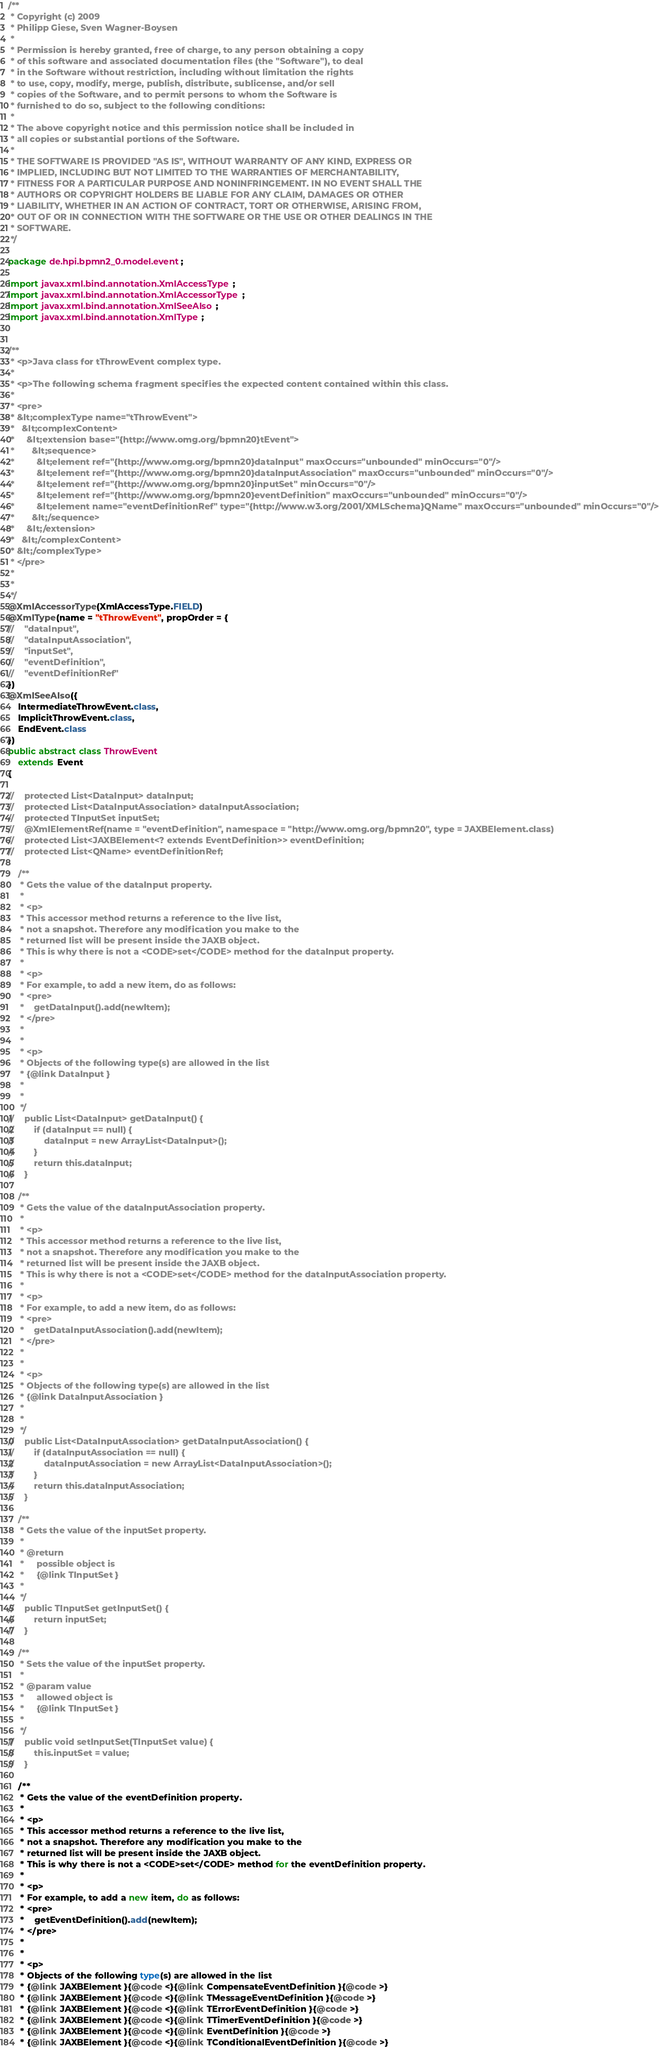<code> <loc_0><loc_0><loc_500><loc_500><_Java_>/**
 * Copyright (c) 2009
 * Philipp Giese, Sven Wagner-Boysen
 * 
 * Permission is hereby granted, free of charge, to any person obtaining a copy
 * of this software and associated documentation files (the "Software"), to deal
 * in the Software without restriction, including without limitation the rights
 * to use, copy, modify, merge, publish, distribute, sublicense, and/or sell
 * copies of the Software, and to permit persons to whom the Software is
 * furnished to do so, subject to the following conditions:
 * 
 * The above copyright notice and this permission notice shall be included in
 * all copies or substantial portions of the Software.
 * 
 * THE SOFTWARE IS PROVIDED "AS IS", WITHOUT WARRANTY OF ANY KIND, EXPRESS OR
 * IMPLIED, INCLUDING BUT NOT LIMITED TO THE WARRANTIES OF MERCHANTABILITY,
 * FITNESS FOR A PARTICULAR PURPOSE AND NONINFRINGEMENT. IN NO EVENT SHALL THE
 * AUTHORS OR COPYRIGHT HOLDERS BE LIABLE FOR ANY CLAIM, DAMAGES OR OTHER
 * LIABILITY, WHETHER IN AN ACTION OF CONTRACT, TORT OR OTHERWISE, ARISING FROM,
 * OUT OF OR IN CONNECTION WITH THE SOFTWARE OR THE USE OR OTHER DEALINGS IN THE
 * SOFTWARE.
 */

package de.hpi.bpmn2_0.model.event;

import javax.xml.bind.annotation.XmlAccessType;
import javax.xml.bind.annotation.XmlAccessorType;
import javax.xml.bind.annotation.XmlSeeAlso;
import javax.xml.bind.annotation.XmlType;


/**
 * <p>Java class for tThrowEvent complex type.
 * 
 * <p>The following schema fragment specifies the expected content contained within this class.
 * 
 * <pre>
 * &lt;complexType name="tThrowEvent">
 *   &lt;complexContent>
 *     &lt;extension base="{http://www.omg.org/bpmn20}tEvent">
 *       &lt;sequence>
 *         &lt;element ref="{http://www.omg.org/bpmn20}dataInput" maxOccurs="unbounded" minOccurs="0"/>
 *         &lt;element ref="{http://www.omg.org/bpmn20}dataInputAssociation" maxOccurs="unbounded" minOccurs="0"/>
 *         &lt;element ref="{http://www.omg.org/bpmn20}inputSet" minOccurs="0"/>
 *         &lt;element ref="{http://www.omg.org/bpmn20}eventDefinition" maxOccurs="unbounded" minOccurs="0"/>
 *         &lt;element name="eventDefinitionRef" type="{http://www.w3.org/2001/XMLSchema}QName" maxOccurs="unbounded" minOccurs="0"/>
 *       &lt;/sequence>
 *     &lt;/extension>
 *   &lt;/complexContent>
 * &lt;/complexType>
 * </pre>
 * 
 * 
 */
@XmlAccessorType(XmlAccessType.FIELD)
@XmlType(name = "tThrowEvent", propOrder = {
//    "dataInput",
//    "dataInputAssociation",
//    "inputSet",
//    "eventDefinition",
//    "eventDefinitionRef"
})
@XmlSeeAlso({
    IntermediateThrowEvent.class,
    ImplicitThrowEvent.class,
    EndEvent.class
})
public abstract class ThrowEvent
    extends Event
{

//    protected List<DataInput> dataInput;
//    protected List<DataInputAssociation> dataInputAssociation;
//    protected TInputSet inputSet;
//    @XmlElementRef(name = "eventDefinition", namespace = "http://www.omg.org/bpmn20", type = JAXBElement.class)
//    protected List<JAXBElement<? extends EventDefinition>> eventDefinition;
//    protected List<QName> eventDefinitionRef;

    /**
     * Gets the value of the dataInput property.
     * 
     * <p>
     * This accessor method returns a reference to the live list,
     * not a snapshot. Therefore any modification you make to the
     * returned list will be present inside the JAXB object.
     * This is why there is not a <CODE>set</CODE> method for the dataInput property.
     * 
     * <p>
     * For example, to add a new item, do as follows:
     * <pre>
     *    getDataInput().add(newItem);
     * </pre>
     * 
     * 
     * <p>
     * Objects of the following type(s) are allowed in the list
     * {@link DataInput }
     * 
     * 
     */
//    public List<DataInput> getDataInput() {
//        if (dataInput == null) {
//            dataInput = new ArrayList<DataInput>();
//        }
//        return this.dataInput;
//    }

    /**
     * Gets the value of the dataInputAssociation property.
     * 
     * <p>
     * This accessor method returns a reference to the live list,
     * not a snapshot. Therefore any modification you make to the
     * returned list will be present inside the JAXB object.
     * This is why there is not a <CODE>set</CODE> method for the dataInputAssociation property.
     * 
     * <p>
     * For example, to add a new item, do as follows:
     * <pre>
     *    getDataInputAssociation().add(newItem);
     * </pre>
     * 
     * 
     * <p>
     * Objects of the following type(s) are allowed in the list
     * {@link DataInputAssociation }
     * 
     * 
     */
//    public List<DataInputAssociation> getDataInputAssociation() {
//        if (dataInputAssociation == null) {
//            dataInputAssociation = new ArrayList<DataInputAssociation>();
//        }
//        return this.dataInputAssociation;
//    }

    /**
     * Gets the value of the inputSet property.
     * 
     * @return
     *     possible object is
     *     {@link TInputSet }
     *     
     */
//    public TInputSet getInputSet() {
//        return inputSet;
//    }

    /**
     * Sets the value of the inputSet property.
     * 
     * @param value
     *     allowed object is
     *     {@link TInputSet }
     *     
     */
//    public void setInputSet(TInputSet value) {
//        this.inputSet = value;
//    }

    /**
     * Gets the value of the eventDefinition property.
     * 
     * <p>
     * This accessor method returns a reference to the live list,
     * not a snapshot. Therefore any modification you make to the
     * returned list will be present inside the JAXB object.
     * This is why there is not a <CODE>set</CODE> method for the eventDefinition property.
     * 
     * <p>
     * For example, to add a new item, do as follows:
     * <pre>
     *    getEventDefinition().add(newItem);
     * </pre>
     * 
     * 
     * <p>
     * Objects of the following type(s) are allowed in the list
     * {@link JAXBElement }{@code <}{@link CompensateEventDefinition }{@code >}
     * {@link JAXBElement }{@code <}{@link TMessageEventDefinition }{@code >}
     * {@link JAXBElement }{@code <}{@link TErrorEventDefinition }{@code >}
     * {@link JAXBElement }{@code <}{@link TTimerEventDefinition }{@code >}
     * {@link JAXBElement }{@code <}{@link EventDefinition }{@code >}
     * {@link JAXBElement }{@code <}{@link TConditionalEventDefinition }{@code >}</code> 